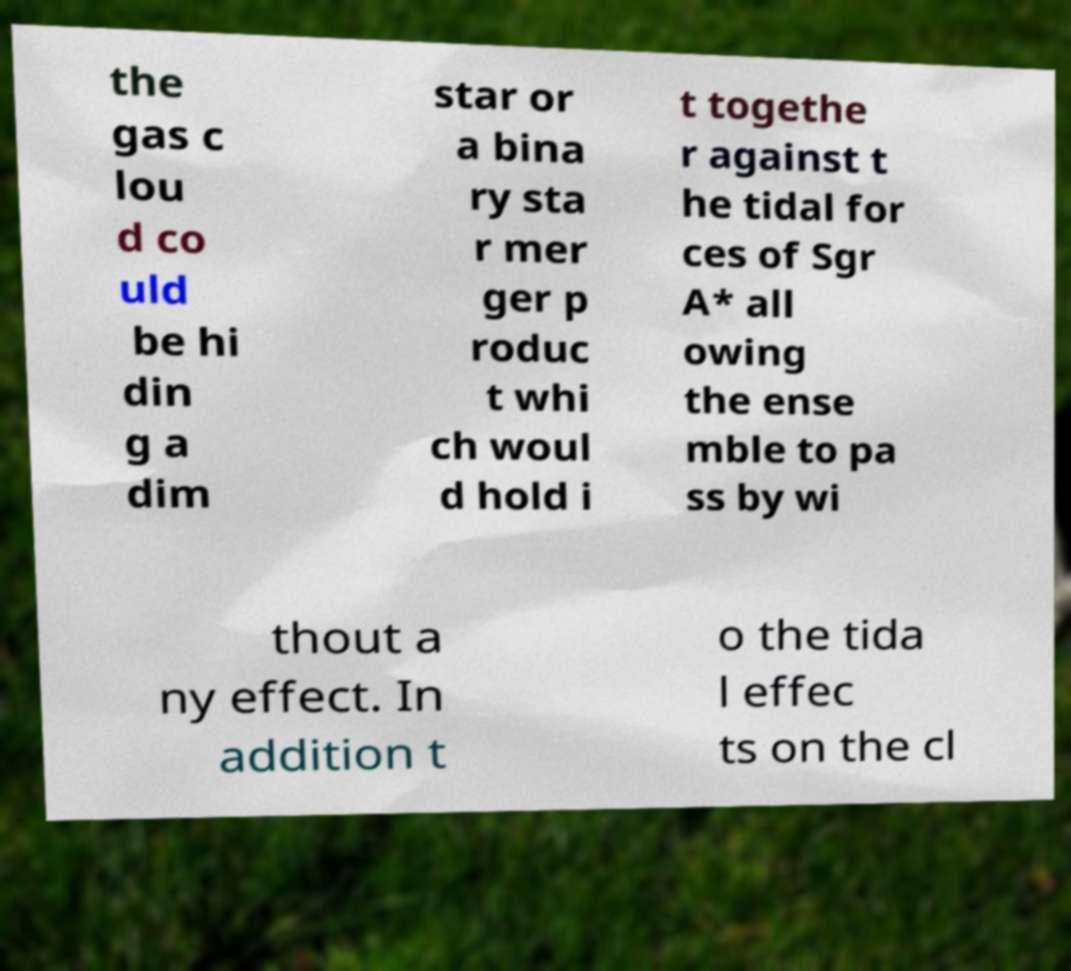For documentation purposes, I need the text within this image transcribed. Could you provide that? the gas c lou d co uld be hi din g a dim star or a bina ry sta r mer ger p roduc t whi ch woul d hold i t togethe r against t he tidal for ces of Sgr A* all owing the ense mble to pa ss by wi thout a ny effect. In addition t o the tida l effec ts on the cl 